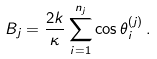<formula> <loc_0><loc_0><loc_500><loc_500>B _ { j } = \frac { 2 k } { \kappa } \sum _ { i = 1 } ^ { n _ { j } } \cos \theta _ { i } ^ { ( j ) } \, .</formula> 